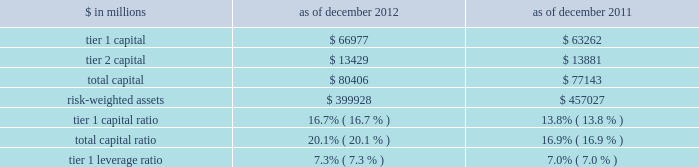Notes to consolidated financial statements note 20 .
Regulation and capital adequacy the federal reserve board is the primary regulator of group inc. , a bank holding company under the bank holding company act of 1956 ( bhc act ) and a financial holding company under amendments to the bhc act effected by the u.s .
Gramm-leach-bliley act of 1999 .
As a bank holding company , the firm is subject to consolidated regulatory capital requirements that are computed in accordance with the federal reserve board 2019s risk-based capital requirements ( which are based on the 2018basel 1 2019 capital accord of the basel committee ) .
These capital requirements are expressed as capital ratios that compare measures of capital to risk-weighted assets ( rwas ) .
The firm 2019s u.s .
Bank depository institution subsidiaries , including gs bank usa , are subject to similar capital requirements .
Under the federal reserve board 2019s capital adequacy requirements and the regulatory framework for prompt corrective action that is applicable to gs bank usa , the firm and its u.s .
Bank depository institution subsidiaries must meet specific capital requirements that involve quantitative measures of assets , liabilities and certain off- balance-sheet items as calculated under regulatory reporting practices .
The firm and its u.s .
Bank depository institution subsidiaries 2019 capital amounts , as well as gs bank usa 2019s prompt corrective action classification , are also subject to qualitative judgments by the regulators about components , risk weightings and other factors .
Many of the firm 2019s subsidiaries , including gs&co .
And the firm 2019s other broker-dealer subsidiaries , are subject to separate regulation and capital requirements as described below .
Group inc .
Federal reserve board regulations require bank holding companies to maintain a minimum tier 1 capital ratio of 4% ( 4 % ) and a minimum total capital ratio of 8% ( 8 % ) .
The required minimum tier 1 capital ratio and total capital ratio in order to be considered a 201cwell-capitalized 201d bank holding company under the federal reserve board guidelines are 6% ( 6 % ) and 10% ( 10 % ) , respectively .
Bank holding companies may be expected to maintain ratios well above the minimum levels , depending on their particular condition , risk profile and growth plans .
The minimum tier 1 leverage ratio is 3% ( 3 % ) for bank holding companies that have received the highest supervisory rating under federal reserve board guidelines or that have implemented the federal reserve board 2019s risk-based capital measure for market risk .
Other bank holding companies must have a minimum tier 1 leverage ratio of 4% ( 4 % ) .
The table below presents information regarding group inc . 2019s regulatory capital ratios. .
Rwas under the federal reserve board 2019s risk-based capital requirements are calculated based on the amount of market risk and credit risk .
Rwas for market risk are determined by reference to the firm 2019s value-at-risk ( var ) model , supplemented by other measures to capture risks not reflected in the firm 2019s var model .
Credit risk for on- balance sheet assets is based on the balance sheet value .
For off-balance sheet exposures , including otc derivatives and commitments , a credit equivalent amount is calculated based on the notional amount of each trade .
All such assets and exposures are then assigned a risk weight depending on , among other things , whether the counterparty is a sovereign , bank or a qualifying securities firm or other entity ( or if collateral is held , depending on the nature of the collateral ) .
Tier 1 leverage ratio is defined as tier 1 capital under basel 1 divided by average adjusted total assets ( which includes adjustments for disallowed goodwill and intangible assets , and the carrying value of equity investments in non-financial companies that are subject to deductions from tier 1 capital ) .
184 goldman sachs 2012 annual report .
What was the change in tier 1 capital in millions between 2011 and 2012? 
Computations: (66977 - 63262)
Answer: 3715.0. 